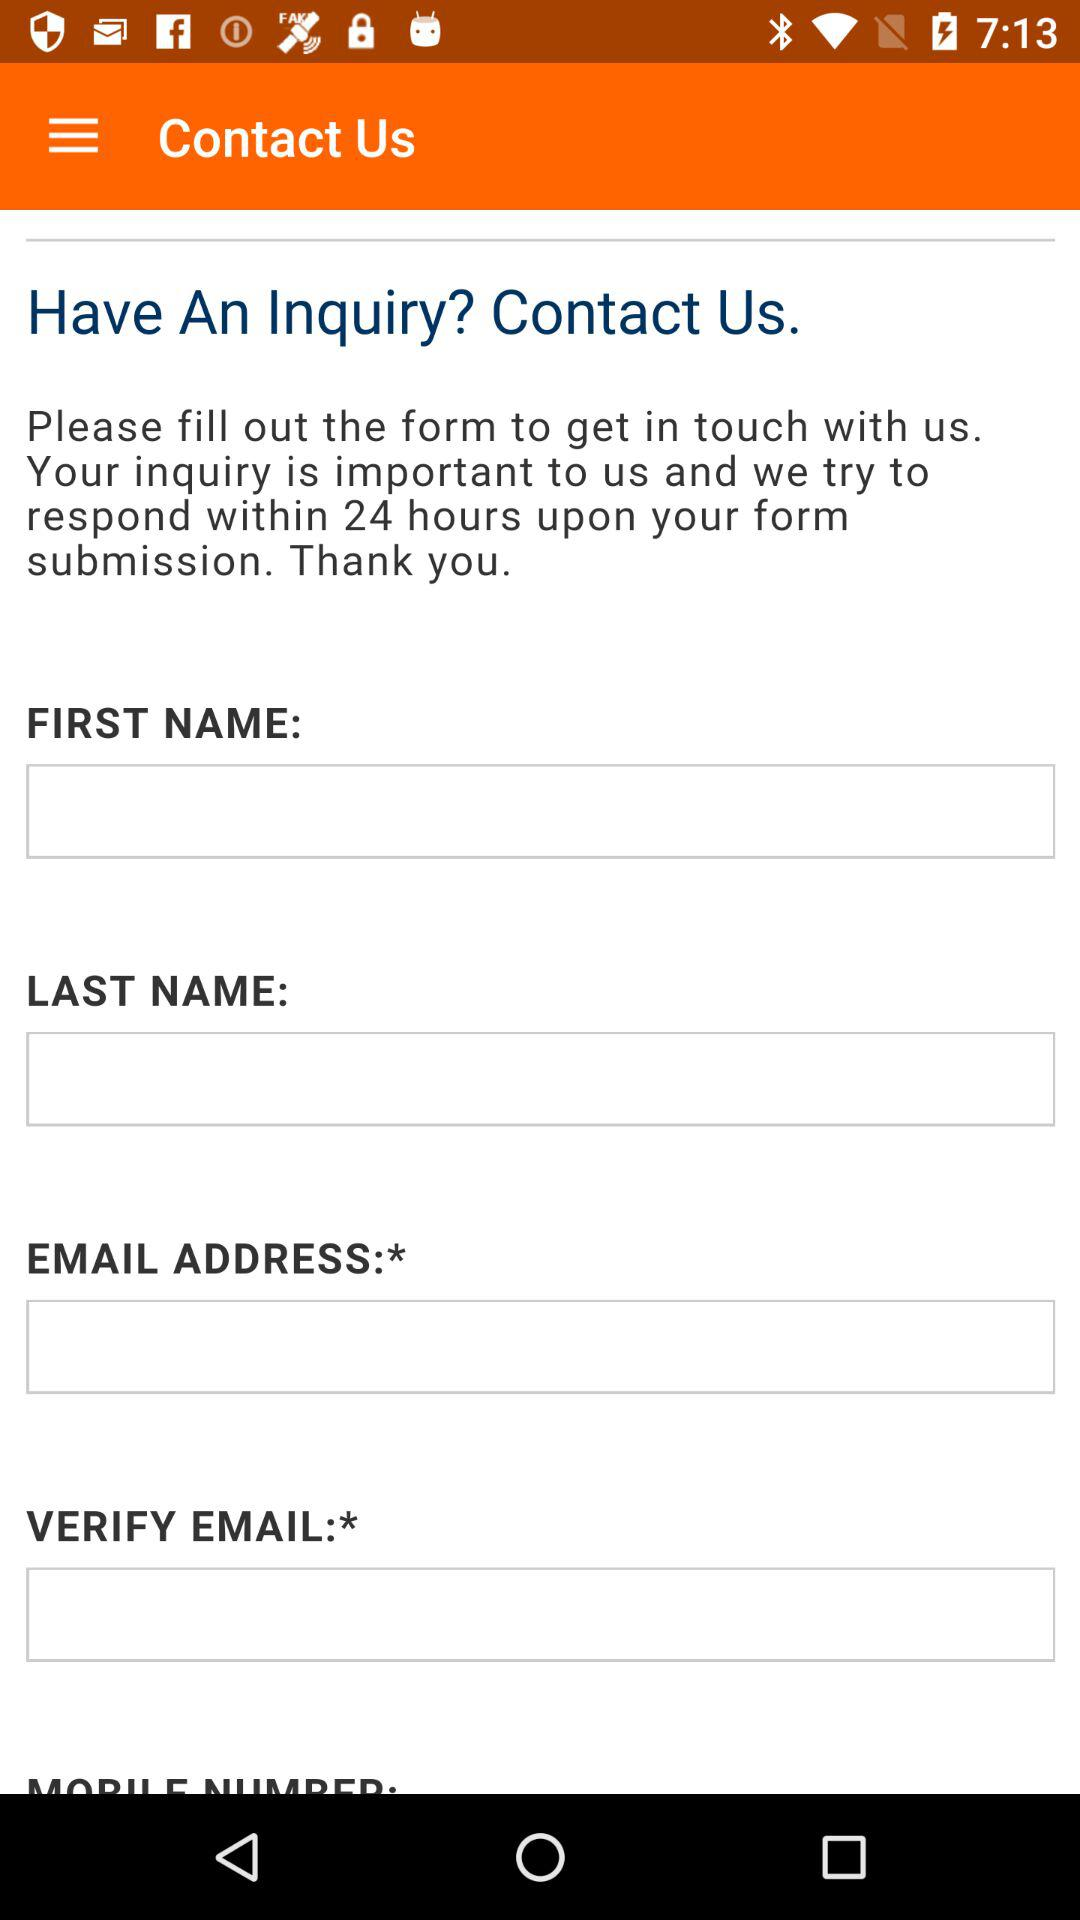How many text inputs are required for the user to fill out?
Answer the question using a single word or phrase. 4 